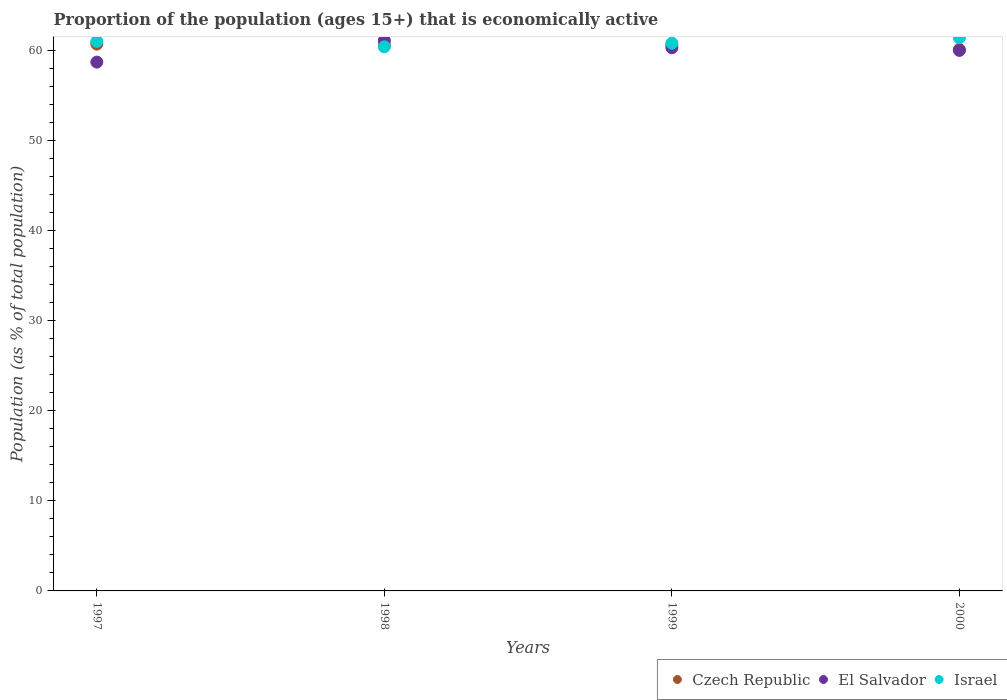How many different coloured dotlines are there?
Keep it short and to the point. 3. Is the number of dotlines equal to the number of legend labels?
Your response must be concise. Yes. What is the proportion of the population that is economically active in El Salvador in 1999?
Your answer should be compact. 60.3. Across all years, what is the maximum proportion of the population that is economically active in El Salvador?
Give a very brief answer. 61.1. Across all years, what is the minimum proportion of the population that is economically active in Czech Republic?
Keep it short and to the point. 60.1. In which year was the proportion of the population that is economically active in Israel maximum?
Provide a short and direct response. 2000. What is the total proportion of the population that is economically active in Israel in the graph?
Your answer should be compact. 243.6. What is the difference between the proportion of the population that is economically active in Israel in 1999 and that in 2000?
Your answer should be very brief. -0.6. What is the difference between the proportion of the population that is economically active in Czech Republic in 1999 and the proportion of the population that is economically active in El Salvador in 2000?
Your response must be concise. 0.6. What is the average proportion of the population that is economically active in Czech Republic per year?
Your answer should be compact. 60.5. In the year 1998, what is the difference between the proportion of the population that is economically active in El Salvador and proportion of the population that is economically active in Israel?
Make the answer very short. 0.7. What is the ratio of the proportion of the population that is economically active in Israel in 1997 to that in 1998?
Your answer should be compact. 1.01. Is the proportion of the population that is economically active in Israel in 1997 less than that in 1998?
Offer a terse response. No. What is the difference between the highest and the second highest proportion of the population that is economically active in El Salvador?
Make the answer very short. 0.8. What is the difference between the highest and the lowest proportion of the population that is economically active in Czech Republic?
Offer a very short reply. 0.6. In how many years, is the proportion of the population that is economically active in Czech Republic greater than the average proportion of the population that is economically active in Czech Republic taken over all years?
Make the answer very short. 3. Is it the case that in every year, the sum of the proportion of the population that is economically active in Israel and proportion of the population that is economically active in El Salvador  is greater than the proportion of the population that is economically active in Czech Republic?
Make the answer very short. Yes. How many dotlines are there?
Provide a short and direct response. 3. How many years are there in the graph?
Your response must be concise. 4. What is the difference between two consecutive major ticks on the Y-axis?
Ensure brevity in your answer.  10. Are the values on the major ticks of Y-axis written in scientific E-notation?
Your answer should be very brief. No. Where does the legend appear in the graph?
Your answer should be very brief. Bottom right. How are the legend labels stacked?
Keep it short and to the point. Horizontal. What is the title of the graph?
Offer a terse response. Proportion of the population (ages 15+) that is economically active. Does "Ecuador" appear as one of the legend labels in the graph?
Make the answer very short. No. What is the label or title of the Y-axis?
Offer a very short reply. Population (as % of total population). What is the Population (as % of total population) in Czech Republic in 1997?
Offer a terse response. 60.7. What is the Population (as % of total population) in El Salvador in 1997?
Ensure brevity in your answer.  58.7. What is the Population (as % of total population) of Czech Republic in 1998?
Your answer should be very brief. 60.6. What is the Population (as % of total population) in El Salvador in 1998?
Your answer should be very brief. 61.1. What is the Population (as % of total population) in Israel in 1998?
Ensure brevity in your answer.  60.4. What is the Population (as % of total population) of Czech Republic in 1999?
Ensure brevity in your answer.  60.6. What is the Population (as % of total population) of El Salvador in 1999?
Keep it short and to the point. 60.3. What is the Population (as % of total population) of Israel in 1999?
Give a very brief answer. 60.8. What is the Population (as % of total population) in Czech Republic in 2000?
Provide a succinct answer. 60.1. What is the Population (as % of total population) in El Salvador in 2000?
Your answer should be very brief. 60. What is the Population (as % of total population) of Israel in 2000?
Make the answer very short. 61.4. Across all years, what is the maximum Population (as % of total population) in Czech Republic?
Your answer should be very brief. 60.7. Across all years, what is the maximum Population (as % of total population) in El Salvador?
Make the answer very short. 61.1. Across all years, what is the maximum Population (as % of total population) of Israel?
Your response must be concise. 61.4. Across all years, what is the minimum Population (as % of total population) of Czech Republic?
Ensure brevity in your answer.  60.1. Across all years, what is the minimum Population (as % of total population) in El Salvador?
Give a very brief answer. 58.7. Across all years, what is the minimum Population (as % of total population) of Israel?
Your answer should be compact. 60.4. What is the total Population (as % of total population) in Czech Republic in the graph?
Provide a short and direct response. 242. What is the total Population (as % of total population) of El Salvador in the graph?
Offer a terse response. 240.1. What is the total Population (as % of total population) in Israel in the graph?
Provide a succinct answer. 243.6. What is the difference between the Population (as % of total population) in El Salvador in 1997 and that in 1998?
Provide a succinct answer. -2.4. What is the difference between the Population (as % of total population) in Israel in 1997 and that in 1999?
Give a very brief answer. 0.2. What is the difference between the Population (as % of total population) in El Salvador in 1997 and that in 2000?
Make the answer very short. -1.3. What is the difference between the Population (as % of total population) in Israel in 1997 and that in 2000?
Ensure brevity in your answer.  -0.4. What is the difference between the Population (as % of total population) in Czech Republic in 1998 and that in 1999?
Ensure brevity in your answer.  0. What is the difference between the Population (as % of total population) of El Salvador in 1998 and that in 1999?
Your response must be concise. 0.8. What is the difference between the Population (as % of total population) of Israel in 1998 and that in 1999?
Keep it short and to the point. -0.4. What is the difference between the Population (as % of total population) of Czech Republic in 1998 and that in 2000?
Keep it short and to the point. 0.5. What is the difference between the Population (as % of total population) of Czech Republic in 1999 and that in 2000?
Your answer should be compact. 0.5. What is the difference between the Population (as % of total population) of Israel in 1999 and that in 2000?
Offer a very short reply. -0.6. What is the difference between the Population (as % of total population) in Czech Republic in 1997 and the Population (as % of total population) in El Salvador in 1998?
Your answer should be compact. -0.4. What is the difference between the Population (as % of total population) in Czech Republic in 1997 and the Population (as % of total population) in Israel in 1998?
Provide a succinct answer. 0.3. What is the difference between the Population (as % of total population) of El Salvador in 1997 and the Population (as % of total population) of Israel in 1998?
Your answer should be compact. -1.7. What is the difference between the Population (as % of total population) of Czech Republic in 1997 and the Population (as % of total population) of El Salvador in 1999?
Give a very brief answer. 0.4. What is the difference between the Population (as % of total population) of El Salvador in 1997 and the Population (as % of total population) of Israel in 1999?
Offer a very short reply. -2.1. What is the difference between the Population (as % of total population) of Czech Republic in 1997 and the Population (as % of total population) of Israel in 2000?
Offer a terse response. -0.7. What is the difference between the Population (as % of total population) in El Salvador in 1997 and the Population (as % of total population) in Israel in 2000?
Your answer should be very brief. -2.7. What is the difference between the Population (as % of total population) of Czech Republic in 1998 and the Population (as % of total population) of Israel in 1999?
Your answer should be very brief. -0.2. What is the difference between the Population (as % of total population) of Czech Republic in 1998 and the Population (as % of total population) of El Salvador in 2000?
Offer a terse response. 0.6. What is the difference between the Population (as % of total population) in Czech Republic in 1999 and the Population (as % of total population) in El Salvador in 2000?
Your response must be concise. 0.6. What is the difference between the Population (as % of total population) of Czech Republic in 1999 and the Population (as % of total population) of Israel in 2000?
Keep it short and to the point. -0.8. What is the difference between the Population (as % of total population) of El Salvador in 1999 and the Population (as % of total population) of Israel in 2000?
Offer a terse response. -1.1. What is the average Population (as % of total population) in Czech Republic per year?
Your answer should be very brief. 60.5. What is the average Population (as % of total population) in El Salvador per year?
Your response must be concise. 60.02. What is the average Population (as % of total population) of Israel per year?
Offer a terse response. 60.9. In the year 1997, what is the difference between the Population (as % of total population) in Czech Republic and Population (as % of total population) in El Salvador?
Offer a very short reply. 2. In the year 1997, what is the difference between the Population (as % of total population) of El Salvador and Population (as % of total population) of Israel?
Provide a short and direct response. -2.3. In the year 1998, what is the difference between the Population (as % of total population) of Czech Republic and Population (as % of total population) of Israel?
Provide a short and direct response. 0.2. In the year 1998, what is the difference between the Population (as % of total population) in El Salvador and Population (as % of total population) in Israel?
Offer a terse response. 0.7. In the year 1999, what is the difference between the Population (as % of total population) in Czech Republic and Population (as % of total population) in El Salvador?
Keep it short and to the point. 0.3. In the year 1999, what is the difference between the Population (as % of total population) of El Salvador and Population (as % of total population) of Israel?
Your answer should be compact. -0.5. In the year 2000, what is the difference between the Population (as % of total population) in Czech Republic and Population (as % of total population) in El Salvador?
Provide a short and direct response. 0.1. In the year 2000, what is the difference between the Population (as % of total population) in Czech Republic and Population (as % of total population) in Israel?
Your answer should be compact. -1.3. In the year 2000, what is the difference between the Population (as % of total population) in El Salvador and Population (as % of total population) in Israel?
Give a very brief answer. -1.4. What is the ratio of the Population (as % of total population) in El Salvador in 1997 to that in 1998?
Offer a very short reply. 0.96. What is the ratio of the Population (as % of total population) of Israel in 1997 to that in 1998?
Keep it short and to the point. 1.01. What is the ratio of the Population (as % of total population) in El Salvador in 1997 to that in 1999?
Provide a succinct answer. 0.97. What is the ratio of the Population (as % of total population) in Israel in 1997 to that in 1999?
Make the answer very short. 1. What is the ratio of the Population (as % of total population) in El Salvador in 1997 to that in 2000?
Your answer should be very brief. 0.98. What is the ratio of the Population (as % of total population) in El Salvador in 1998 to that in 1999?
Give a very brief answer. 1.01. What is the ratio of the Population (as % of total population) of Israel in 1998 to that in 1999?
Your response must be concise. 0.99. What is the ratio of the Population (as % of total population) of Czech Republic in 1998 to that in 2000?
Ensure brevity in your answer.  1.01. What is the ratio of the Population (as % of total population) of El Salvador in 1998 to that in 2000?
Provide a succinct answer. 1.02. What is the ratio of the Population (as % of total population) in Israel in 1998 to that in 2000?
Offer a terse response. 0.98. What is the ratio of the Population (as % of total population) of Czech Republic in 1999 to that in 2000?
Your answer should be compact. 1.01. What is the ratio of the Population (as % of total population) of El Salvador in 1999 to that in 2000?
Ensure brevity in your answer.  1. What is the ratio of the Population (as % of total population) in Israel in 1999 to that in 2000?
Make the answer very short. 0.99. What is the difference between the highest and the second highest Population (as % of total population) in Israel?
Provide a short and direct response. 0.4. What is the difference between the highest and the lowest Population (as % of total population) of Czech Republic?
Your answer should be very brief. 0.6. 